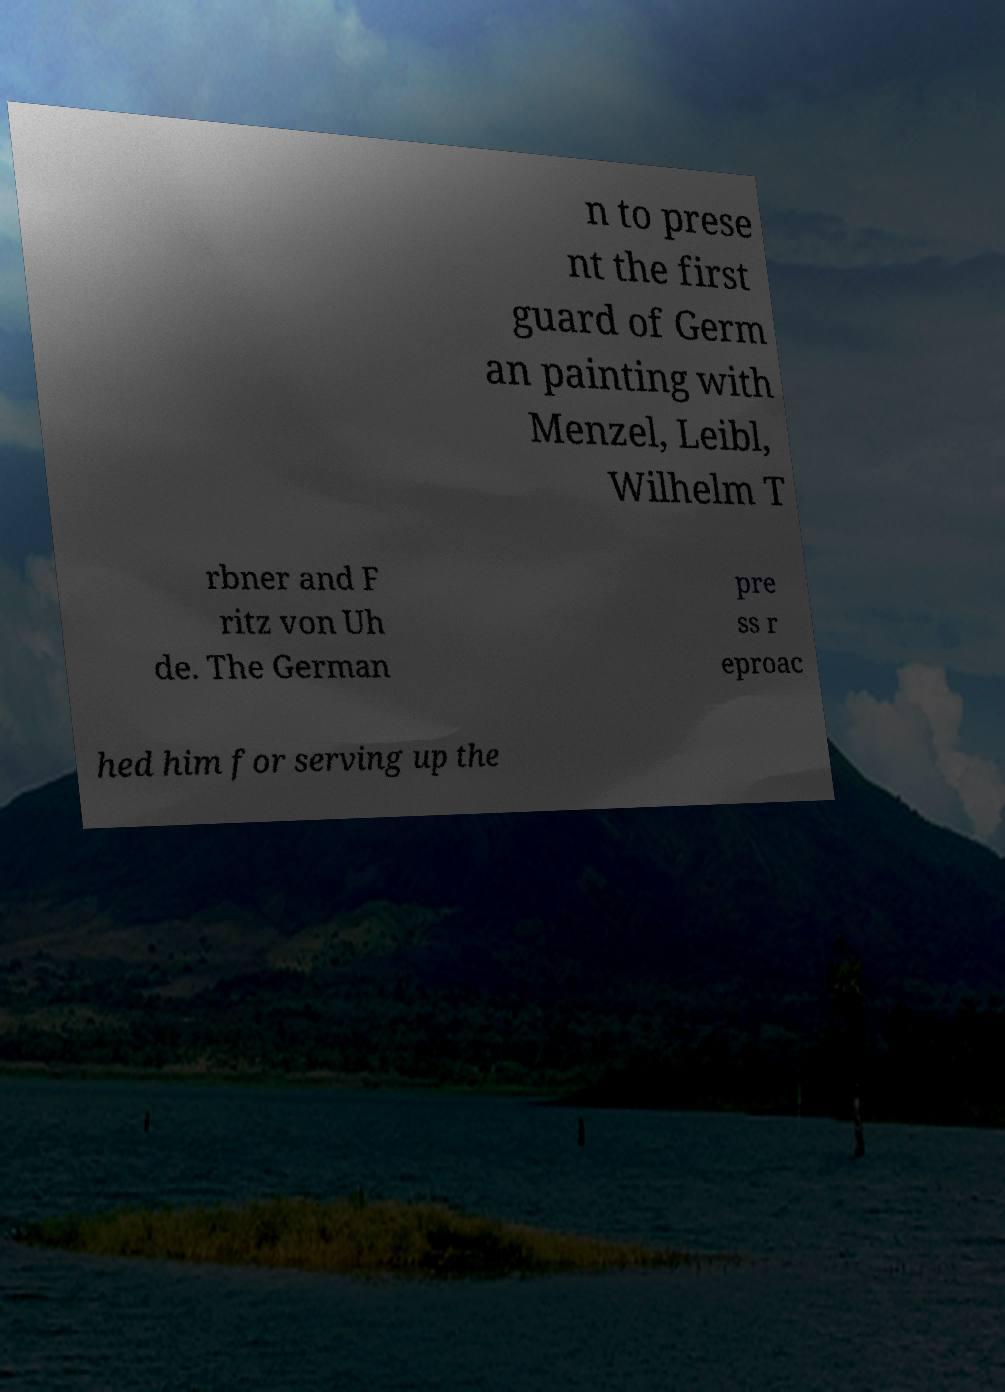There's text embedded in this image that I need extracted. Can you transcribe it verbatim? n to prese nt the first guard of Germ an painting with Menzel, Leibl, Wilhelm T rbner and F ritz von Uh de. The German pre ss r eproac hed him for serving up the 